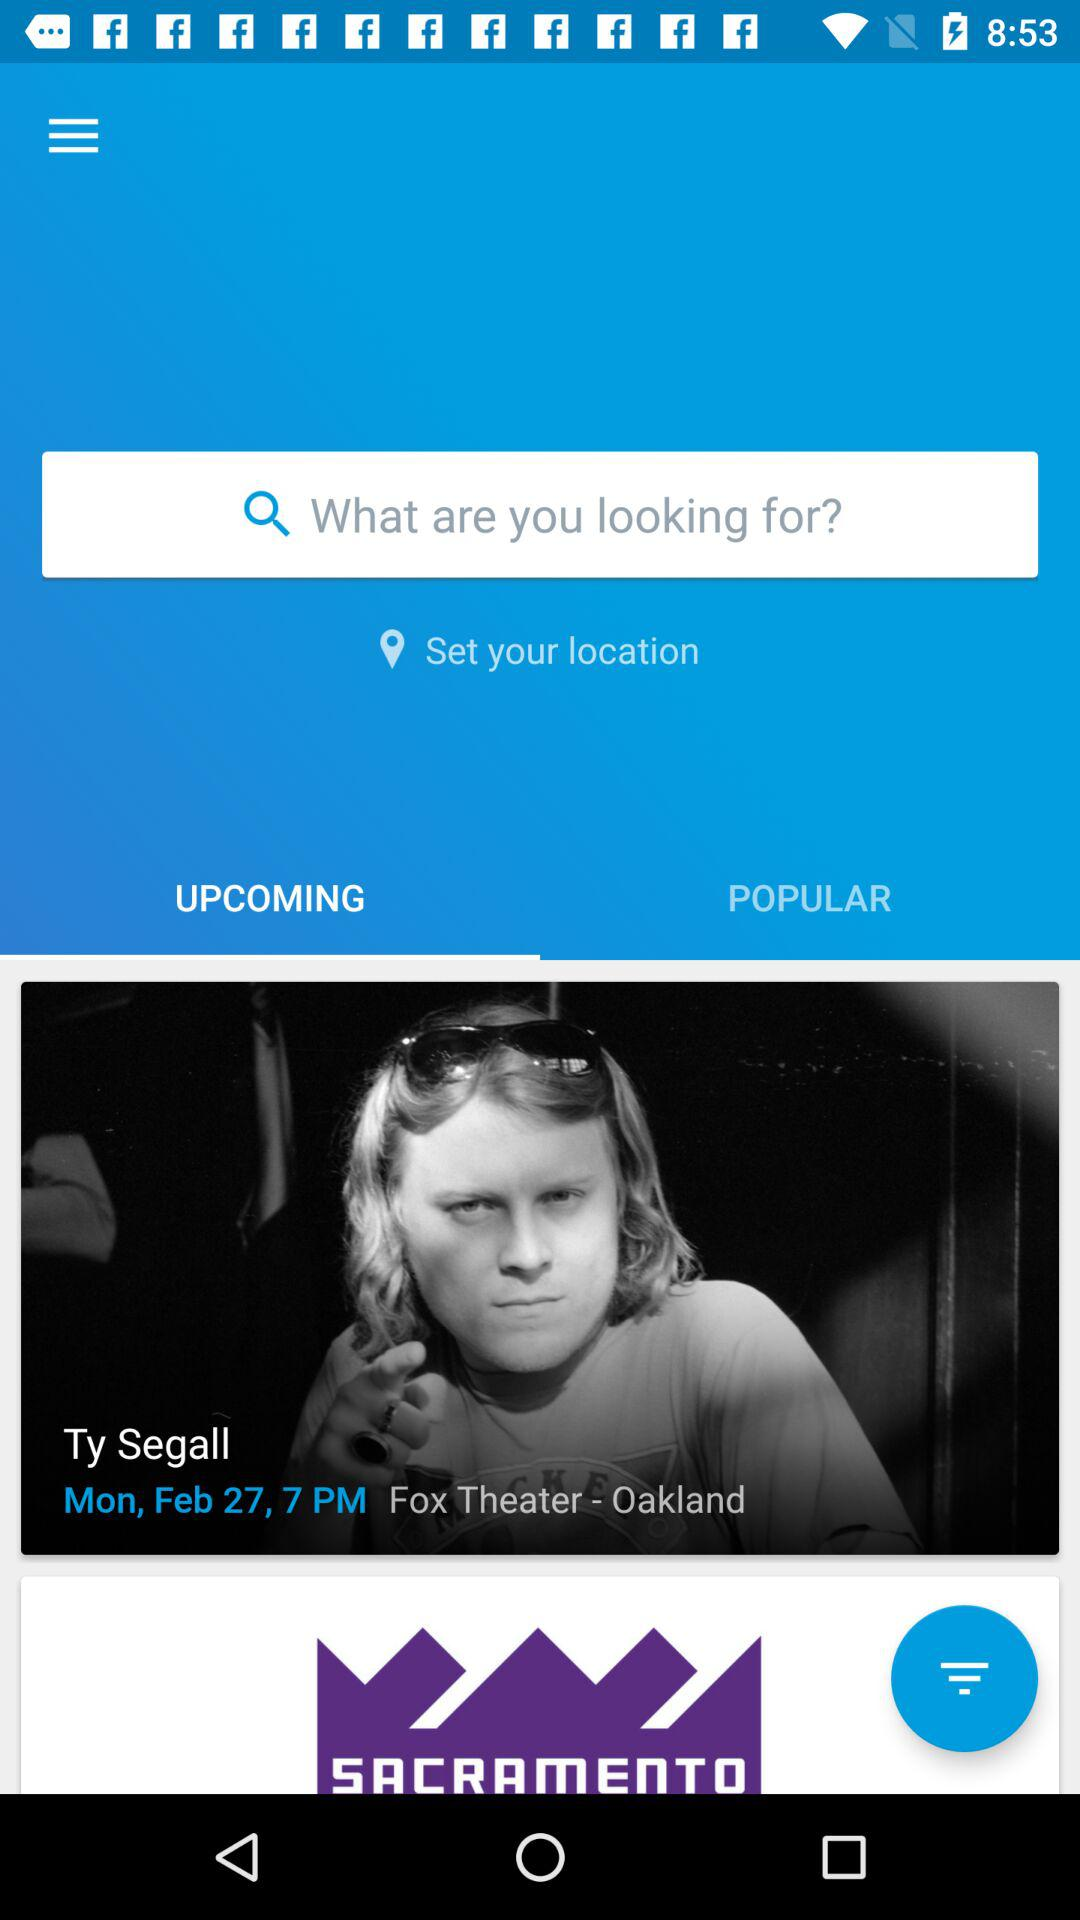What is the date and timing of the upcoming movie? The date and time of the upcoming movie are Monday, February 27 and 7 PM. 